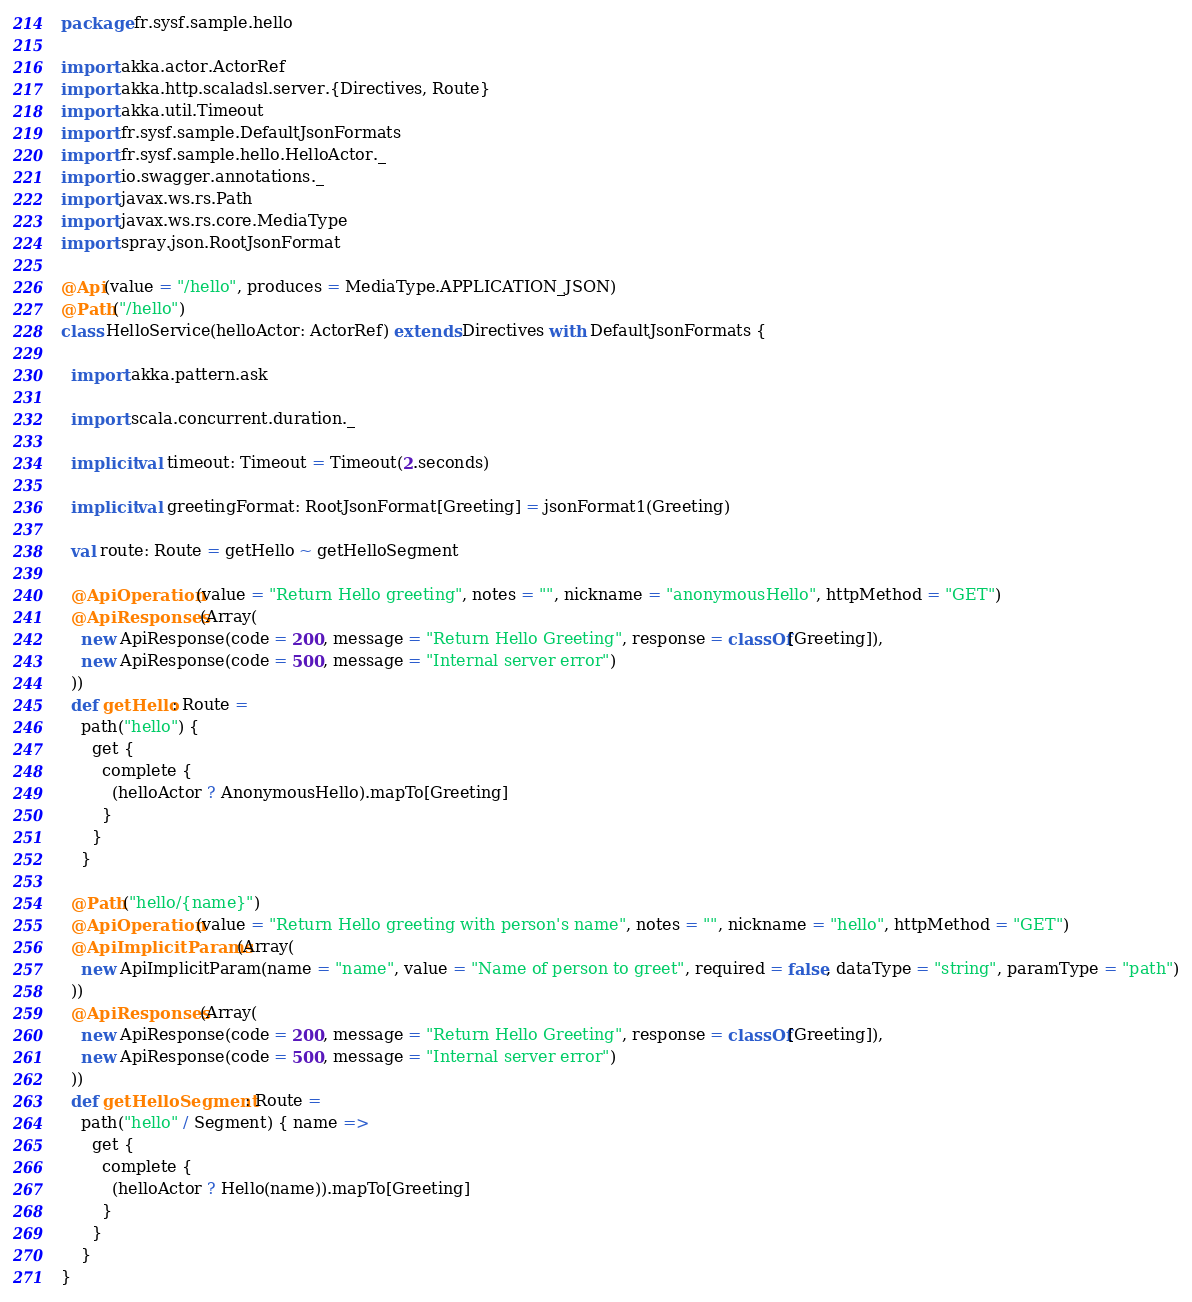<code> <loc_0><loc_0><loc_500><loc_500><_Scala_>package fr.sysf.sample.hello

import akka.actor.ActorRef
import akka.http.scaladsl.server.{Directives, Route}
import akka.util.Timeout
import fr.sysf.sample.DefaultJsonFormats
import fr.sysf.sample.hello.HelloActor._
import io.swagger.annotations._
import javax.ws.rs.Path
import javax.ws.rs.core.MediaType
import spray.json.RootJsonFormat

@Api(value = "/hello", produces = MediaType.APPLICATION_JSON)
@Path("/hello")
class HelloService(helloActor: ActorRef) extends Directives with DefaultJsonFormats {

  import akka.pattern.ask

  import scala.concurrent.duration._

  implicit val timeout: Timeout = Timeout(2.seconds)

  implicit val greetingFormat: RootJsonFormat[Greeting] = jsonFormat1(Greeting)

  val route: Route = getHello ~ getHelloSegment

  @ApiOperation(value = "Return Hello greeting", notes = "", nickname = "anonymousHello", httpMethod = "GET")
  @ApiResponses(Array(
    new ApiResponse(code = 200, message = "Return Hello Greeting", response = classOf[Greeting]),
    new ApiResponse(code = 500, message = "Internal server error")
  ))
  def getHello: Route =
    path("hello") {
      get {
        complete {
          (helloActor ? AnonymousHello).mapTo[Greeting]
        }
      }
    }

  @Path("hello/{name}")
  @ApiOperation(value = "Return Hello greeting with person's name", notes = "", nickname = "hello", httpMethod = "GET")
  @ApiImplicitParams(Array(
    new ApiImplicitParam(name = "name", value = "Name of person to greet", required = false, dataType = "string", paramType = "path")
  ))
  @ApiResponses(Array(
    new ApiResponse(code = 200, message = "Return Hello Greeting", response = classOf[Greeting]),
    new ApiResponse(code = 500, message = "Internal server error")
  ))
  def getHelloSegment: Route =
    path("hello" / Segment) { name =>
      get {
        complete {
          (helloActor ? Hello(name)).mapTo[Greeting]
        }
      }
    }
}

</code> 